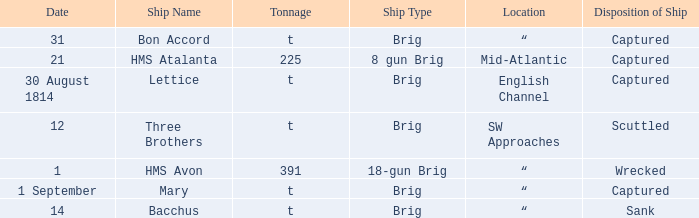Where was the ship when the ship had captured as the disposition of ship and was carrying 225 tonnage? Mid-Atlantic. 